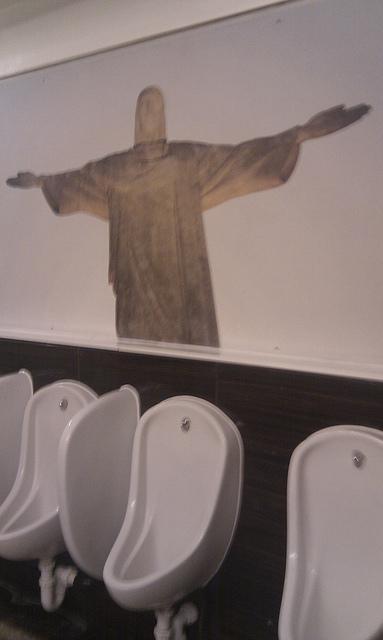How many toilets are in the photo?
Give a very brief answer. 2. 